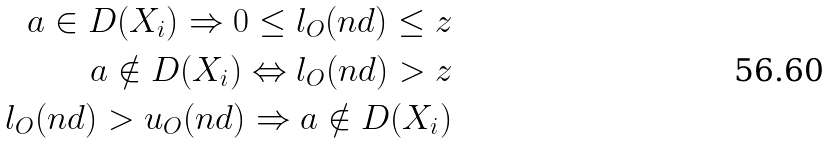<formula> <loc_0><loc_0><loc_500><loc_500>a \in D ( X _ { i } ) \Rightarrow 0 \leq l _ { O } ( n d ) \leq z \\ a \notin D ( X _ { i } ) \Leftrightarrow l _ { O } ( n d ) > z \\ l _ { O } ( n d ) > u _ { O } ( n d ) \Rightarrow a \notin D ( X _ { i } )</formula> 